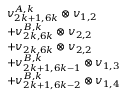<formula> <loc_0><loc_0><loc_500><loc_500>\begin{array} { r l } & { v _ { 2 k + 1 , 6 k } ^ { A , k } \otimes v _ { 1 , 2 } } \\ & { + v _ { 2 k , 6 k } ^ { B , k } \otimes v _ { 2 , 2 } } \\ & { + v _ { 2 k , 6 k } \otimes v _ { 2 , 2 } } \\ & { + v _ { 2 k + 1 , 6 k - 1 } ^ { B , k } \otimes v _ { 1 , 3 } } \\ & { + v _ { 2 k + 1 , 6 k - 2 } ^ { B , k } \otimes v _ { 1 , 4 } } \end{array}</formula> 